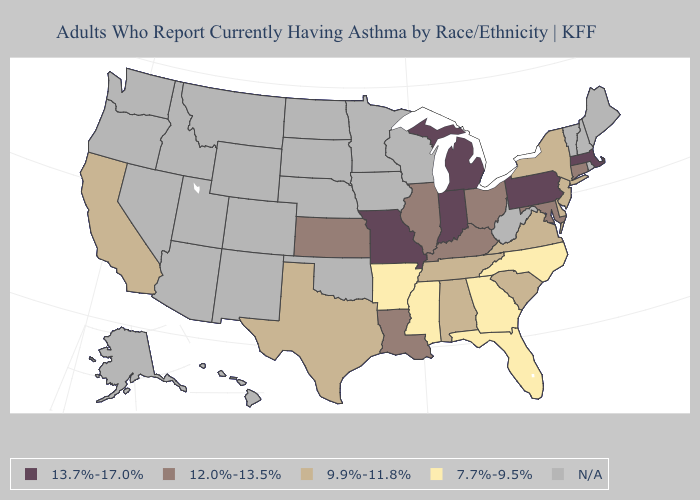What is the highest value in states that border Kentucky?
Be succinct. 13.7%-17.0%. Name the states that have a value in the range 9.9%-11.8%?
Concise answer only. Alabama, California, Delaware, New Jersey, New York, South Carolina, Tennessee, Texas, Virginia. What is the value of South Carolina?
Quick response, please. 9.9%-11.8%. Among the states that border Maryland , does Pennsylvania have the lowest value?
Concise answer only. No. What is the value of North Carolina?
Keep it brief. 7.7%-9.5%. What is the value of Utah?
Short answer required. N/A. What is the lowest value in the West?
Write a very short answer. 9.9%-11.8%. Among the states that border Connecticut , which have the lowest value?
Answer briefly. New York. Name the states that have a value in the range 12.0%-13.5%?
Short answer required. Connecticut, Illinois, Kansas, Kentucky, Louisiana, Maryland, Ohio. What is the highest value in the USA?
Answer briefly. 13.7%-17.0%. Among the states that border Massachusetts , which have the lowest value?
Give a very brief answer. New York. Name the states that have a value in the range N/A?
Quick response, please. Alaska, Arizona, Colorado, Hawaii, Idaho, Iowa, Maine, Minnesota, Montana, Nebraska, Nevada, New Hampshire, New Mexico, North Dakota, Oklahoma, Oregon, Rhode Island, South Dakota, Utah, Vermont, Washington, West Virginia, Wisconsin, Wyoming. What is the lowest value in the USA?
Keep it brief. 7.7%-9.5%. 